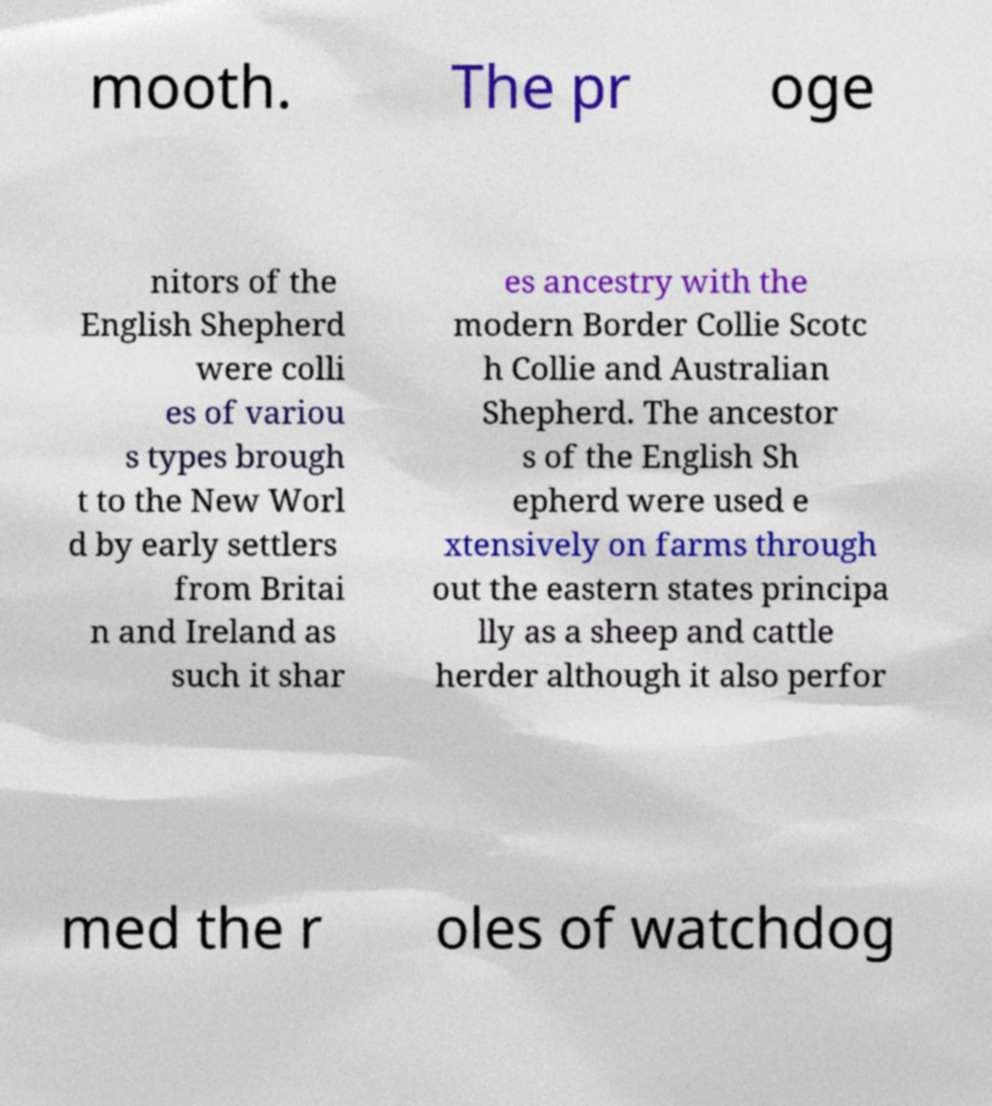There's text embedded in this image that I need extracted. Can you transcribe it verbatim? mooth. The pr oge nitors of the English Shepherd were colli es of variou s types brough t to the New Worl d by early settlers from Britai n and Ireland as such it shar es ancestry with the modern Border Collie Scotc h Collie and Australian Shepherd. The ancestor s of the English Sh epherd were used e xtensively on farms through out the eastern states principa lly as a sheep and cattle herder although it also perfor med the r oles of watchdog 